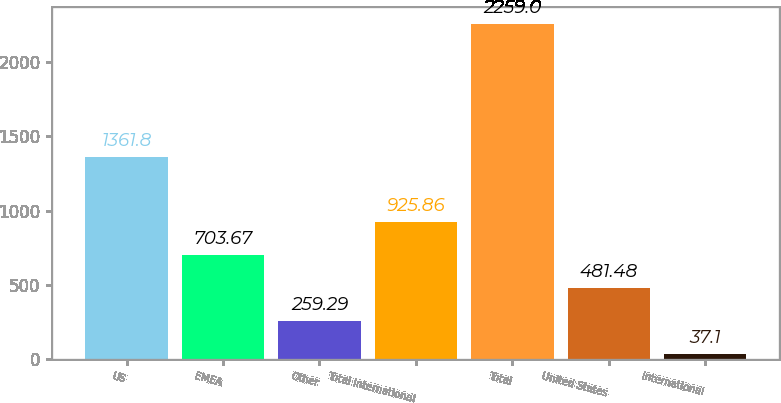Convert chart to OTSL. <chart><loc_0><loc_0><loc_500><loc_500><bar_chart><fcel>US<fcel>EMEA<fcel>Other<fcel>Total International<fcel>Total<fcel>United States<fcel>International<nl><fcel>1361.8<fcel>703.67<fcel>259.29<fcel>925.86<fcel>2259<fcel>481.48<fcel>37.1<nl></chart> 